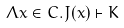Convert formula to latex. <formula><loc_0><loc_0><loc_500><loc_500>\Lambda x \in C . J ( x ) \vdash K</formula> 